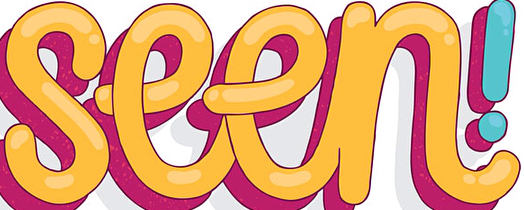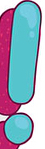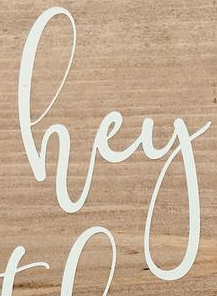Identify the words shown in these images in order, separated by a semicolon. seen; !; hey 